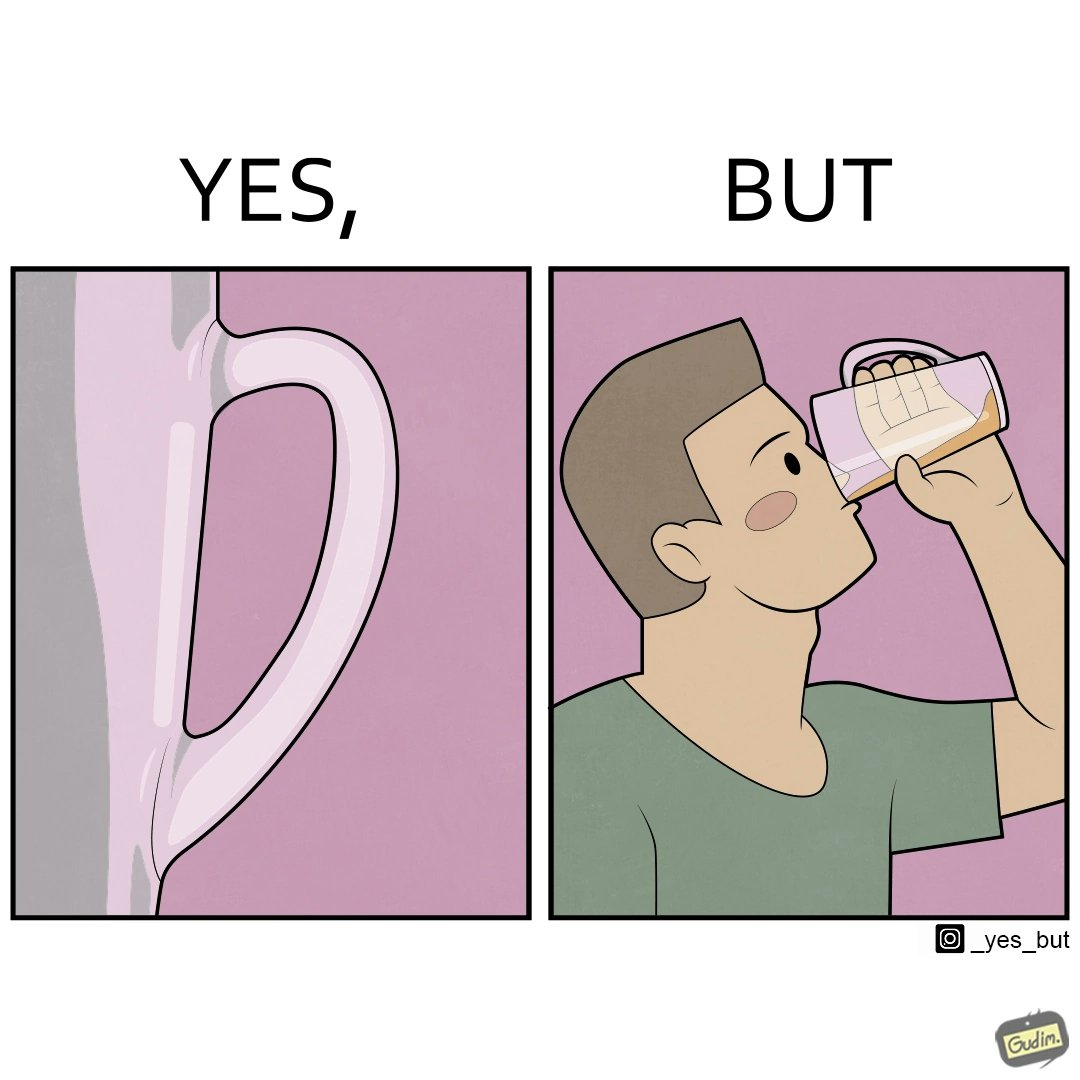Describe what you see in the left and right parts of this image. In the left part of the image: A transparent glass tumbler that has a glass handle on it In the right part of the image: A person drinking something from a glass tumbler. The tumbler has a handle on it. The person is not using the handle, but grabbing the tumbler directly. 